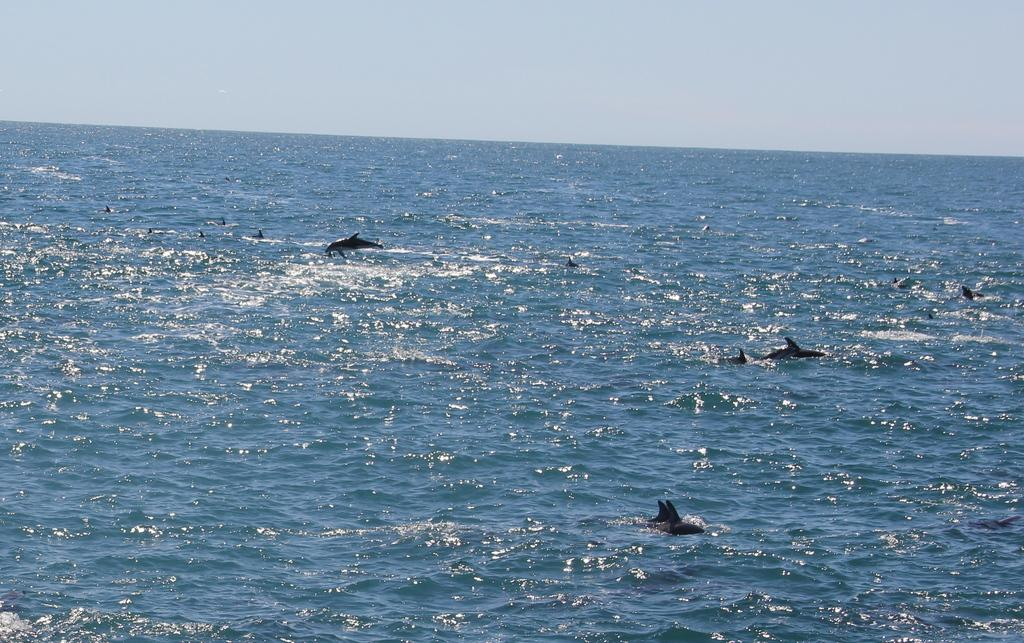What type of animals are in the water in the image? There are dolphins in the water in the image. What body of water might the image depict? The image appears to depict a sea. What action is one of the dolphins performing in the image? A dolphin is jumping in the image. What part of the natural environment is visible in the image? The sky is visible in the image. What arithmetic problem can be solved using the dolphins in the image? There is no arithmetic problem present in the image, as it features dolphins in the water and a sea. What type of grass can be seen growing near the dolphins in the image? There is no grass visible in the image, as it depicts a sea environment. 